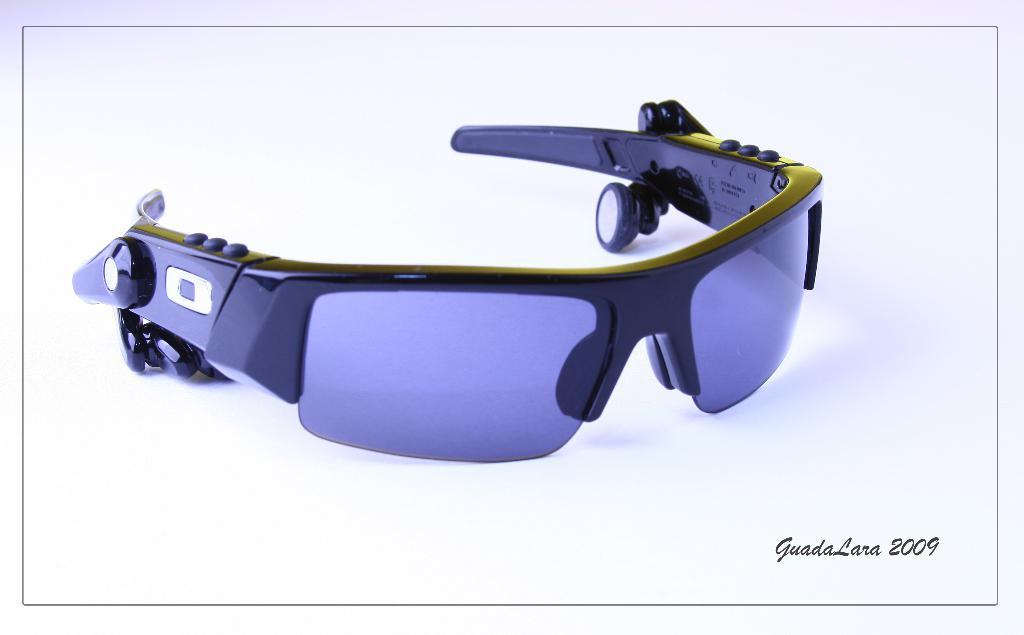What is placed on the floor in the image? There are goggles on the floor in the image. Are the goggles accompanied by any other objects or figures? The image only item on the floor is just the goggles; there are no other objects or figures present. What type of selection process is being conducted by the cub in the image? There is no cub present in the image; it only features goggles on the floor. 